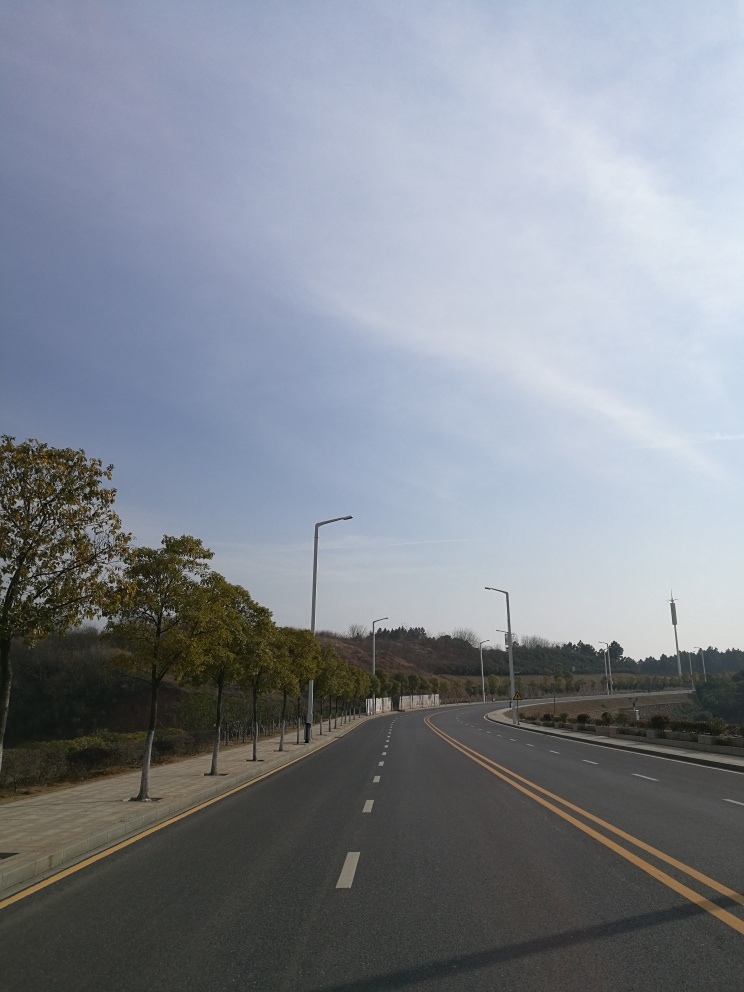Is there anything in this picture that indicates the location or season? The trees beside the road have yellowing leaves, hinting at autumn. There aren't any distinct location indicators, but the style of the street lamps and the road design might provide subtle clues about the region, possibly pointing towards a temperate climate area. 